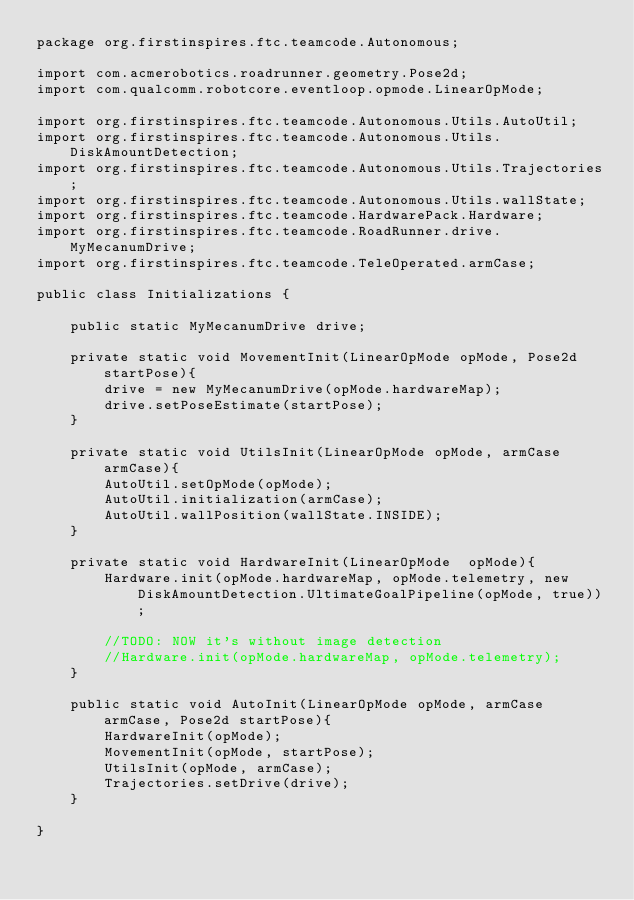<code> <loc_0><loc_0><loc_500><loc_500><_Java_>package org.firstinspires.ftc.teamcode.Autonomous;

import com.acmerobotics.roadrunner.geometry.Pose2d;
import com.qualcomm.robotcore.eventloop.opmode.LinearOpMode;

import org.firstinspires.ftc.teamcode.Autonomous.Utils.AutoUtil;
import org.firstinspires.ftc.teamcode.Autonomous.Utils.DiskAmountDetection;
import org.firstinspires.ftc.teamcode.Autonomous.Utils.Trajectories;
import org.firstinspires.ftc.teamcode.Autonomous.Utils.wallState;
import org.firstinspires.ftc.teamcode.HardwarePack.Hardware;
import org.firstinspires.ftc.teamcode.RoadRunner.drive.MyMecanumDrive;
import org.firstinspires.ftc.teamcode.TeleOperated.armCase;

public class Initializations {

    public static MyMecanumDrive drive;

    private static void MovementInit(LinearOpMode opMode, Pose2d startPose){
        drive = new MyMecanumDrive(opMode.hardwareMap);
        drive.setPoseEstimate(startPose);
    }

    private static void UtilsInit(LinearOpMode opMode, armCase armCase){
        AutoUtil.setOpMode(opMode);
        AutoUtil.initialization(armCase);
        AutoUtil.wallPosition(wallState.INSIDE);
    }

    private static void HardwareInit(LinearOpMode  opMode){
        Hardware.init(opMode.hardwareMap, opMode.telemetry, new DiskAmountDetection.UltimateGoalPipeline(opMode, true));

        //TODO: NOW it's without image detection
        //Hardware.init(opMode.hardwareMap, opMode.telemetry);
    }

    public static void AutoInit(LinearOpMode opMode, armCase armCase, Pose2d startPose){
        HardwareInit(opMode);
        MovementInit(opMode, startPose);
        UtilsInit(opMode, armCase);
        Trajectories.setDrive(drive);
    }

}
</code> 